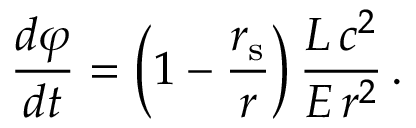<formula> <loc_0><loc_0><loc_500><loc_500>{ \frac { d \varphi } { d t } } = \left ( 1 - { \frac { r _ { s } } { r } } \right ) { \frac { L \, c ^ { 2 } } { E \, r ^ { 2 } } } \, .</formula> 